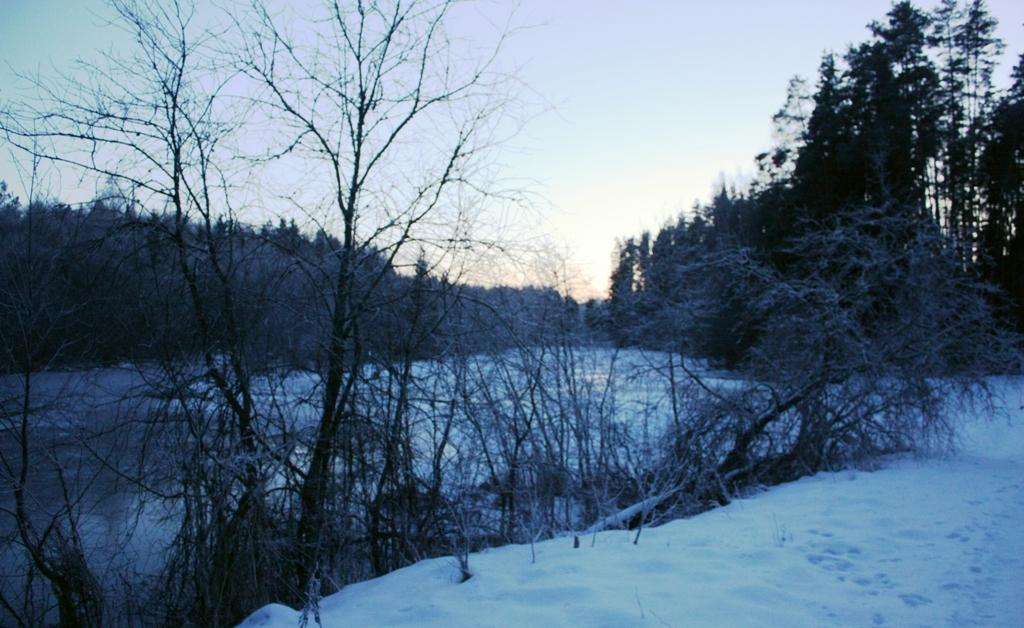What type of vegetation can be seen in the image? There are trees in the image. What is covering the ground in the image? There is snow in the image. What can be seen in the background of the image? The sky is visible in the background of the image. What type of music can be heard playing in the background of the image? There is no music present in the image, as it is a visual representation and does not contain audio. 